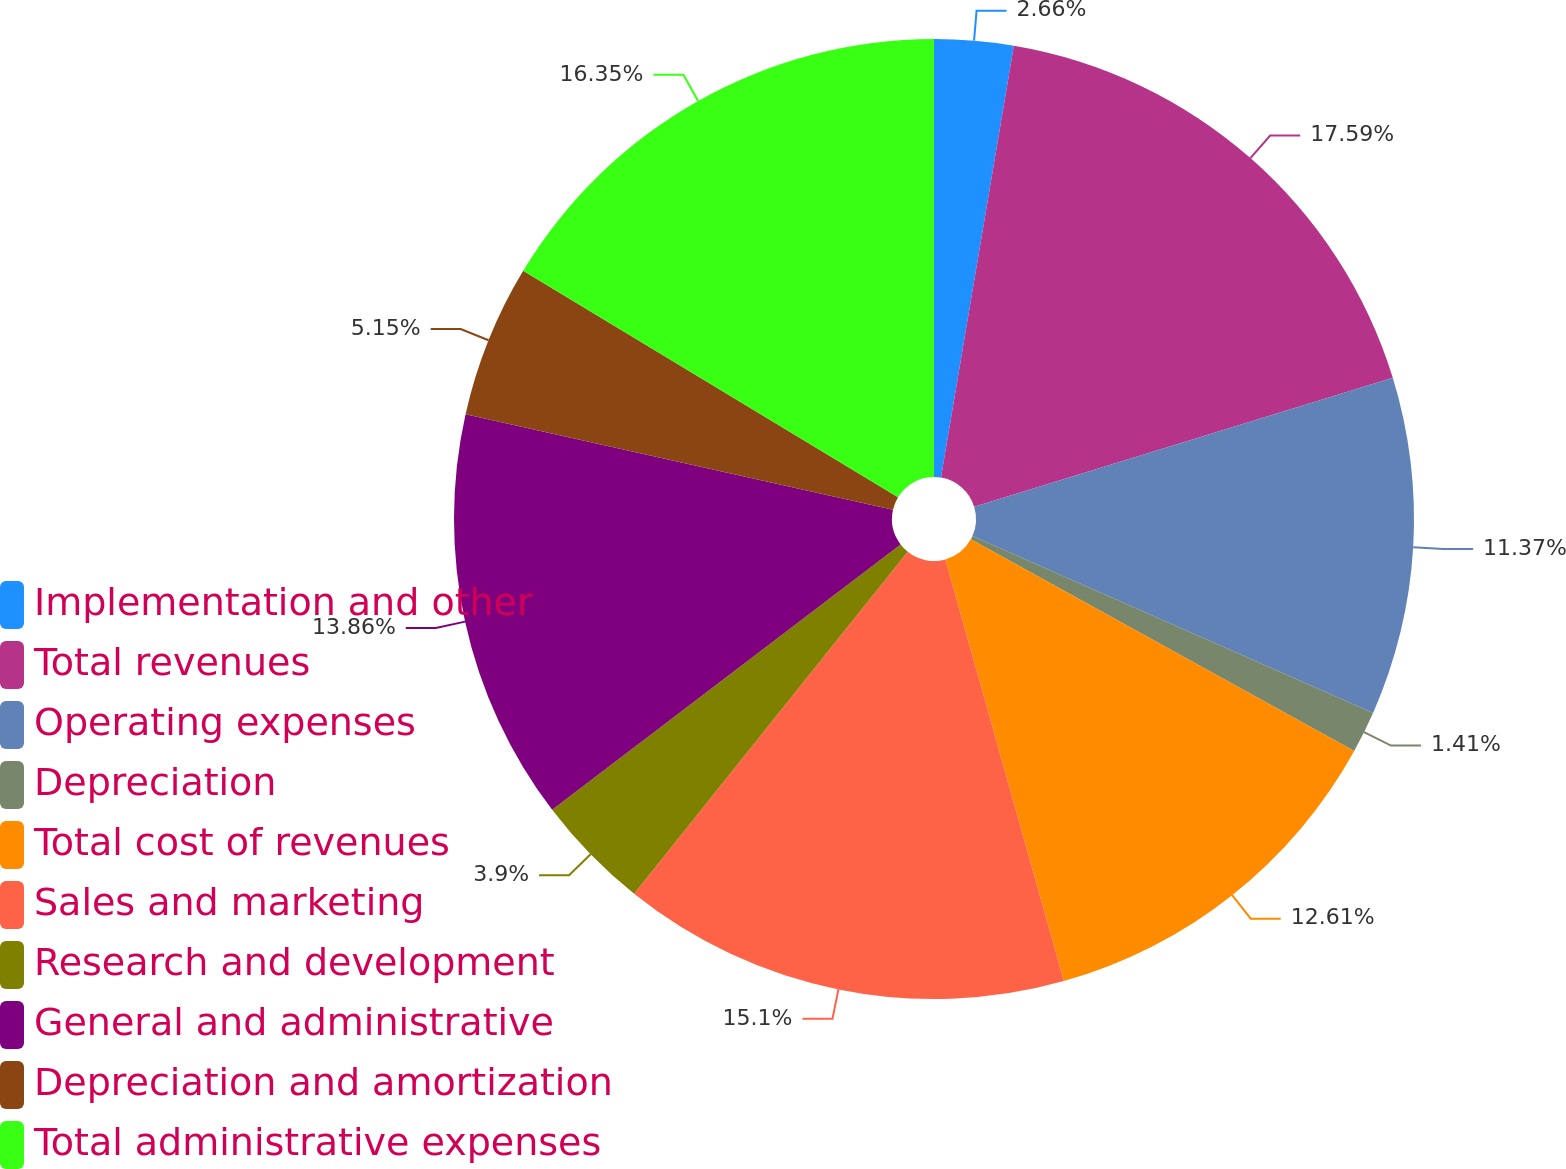<chart> <loc_0><loc_0><loc_500><loc_500><pie_chart><fcel>Implementation and other<fcel>Total revenues<fcel>Operating expenses<fcel>Depreciation<fcel>Total cost of revenues<fcel>Sales and marketing<fcel>Research and development<fcel>General and administrative<fcel>Depreciation and amortization<fcel>Total administrative expenses<nl><fcel>2.66%<fcel>17.59%<fcel>11.37%<fcel>1.41%<fcel>12.61%<fcel>15.1%<fcel>3.9%<fcel>13.86%<fcel>5.15%<fcel>16.35%<nl></chart> 